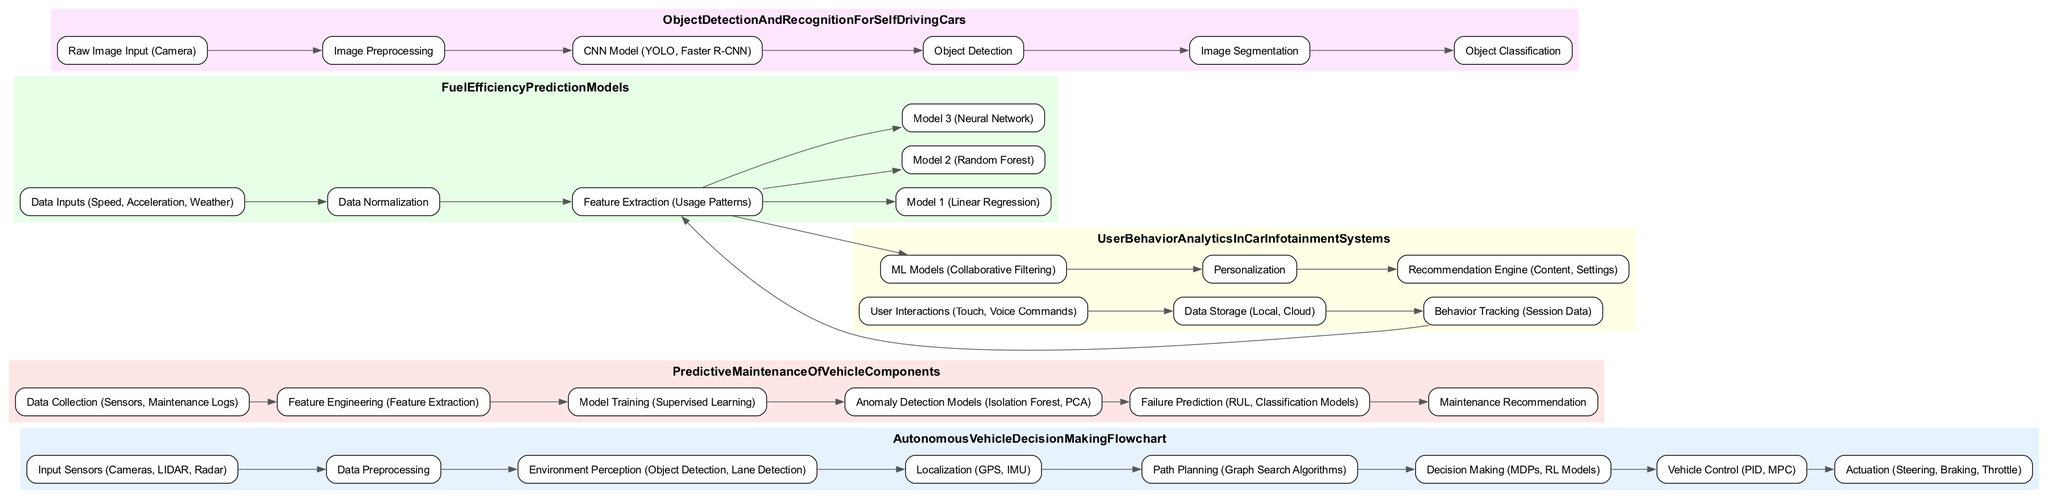What is the first node in the Autonomous Vehicle Decision Making Flowchart? The first node in the Autonomous Vehicle Decision Making Flowchart is "Input Sensors (Cameras, LIDAR, Radar)". This can be seen at the beginning of the flowchart as the starting point of the decision-making process.
Answer: Input Sensors (Cameras, LIDAR, Radar) How many nodes are there in the Predictive Maintenance of Vehicle Components diagram? By counting the individual nodes in the Predictive Maintenance of Vehicle Components diagram, we can find there are a total of six distinct nodes present.
Answer: 6 Which node comes directly after "Feature Engineering" in Predictive Maintenance of Vehicle Components? In the Predictive Maintenance flow, after "Feature Engineering," the next node is "Model Training (Supervised Learning)" as indicated by the directed edge that connects these two nodes.
Answer: Model Training (Supervised Learning) What machine learning models are used in the Fuel Efficiency Prediction Models diagram? The Fuel Efficiency Prediction Models diagram includes three specific machine learning models: "Model 1 (Linear Regression)," "Model 2 (Random Forest)," and "Model 3 (Neural Network)," each represented as nodes linked from the "Feature Extraction" node.
Answer: Model 1 (Linear Regression), Model 2 (Random Forest), Model 3 (Neural Network) How is user behavior tracked in the User Behavior Analytics in Car Infotainment Systems? The user behavior is tracked through the "Behavior Tracking (Session Data)" node, which receives data from the node that collects user interactions after data storage. This node serves as a part of a sequence to analyze how users engage with the system.
Answer: Behavior Tracking (Session Data) What is the last step before "Maintenance Recommendation" in the Predictive Maintenance of Vehicle Components? The last step before reaching the "Maintenance Recommendation" node is "Failure Prediction (RUL, Classification Models)," indicating that predicting failure is necessary to inform the maintenance recommendation process.
Answer: Failure Prediction (RUL, Classification Models) Which component directly follows "Object Detection" in the Object Detection and Recognition for Self-Driving Cars diagram? In the Object Detection and Recognition flowchart, the component that directly follows "Object Detection" is "Image Segmentation," indicating that after detecting objects, the next step involves segmenting these objects for further processing.
Answer: Image Segmentation How do "Data Inputs" relate to "Data Normalization" in the diagram? "Data Inputs" serve as the initial step that feeds into "Data Normalization," which is the process of adjusting the inputs to bring them into a suitable format for further analysis. This relationship is evident as there is a directed edge from "Data Inputs" to "Data Normalization."
Answer: Data Inputs lead to Data Normalization 